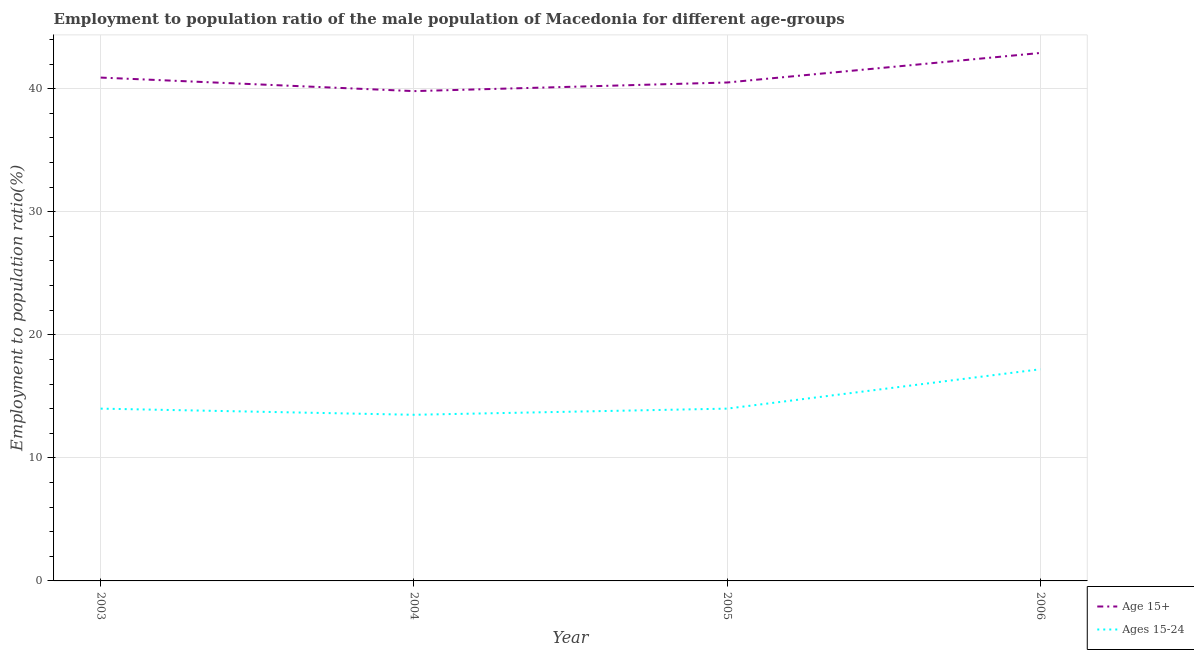What is the employment to population ratio(age 15+) in 2005?
Your response must be concise. 40.5. Across all years, what is the maximum employment to population ratio(age 15-24)?
Provide a short and direct response. 17.2. In which year was the employment to population ratio(age 15-24) minimum?
Provide a short and direct response. 2004. What is the total employment to population ratio(age 15-24) in the graph?
Give a very brief answer. 58.7. What is the difference between the employment to population ratio(age 15+) in 2003 and that in 2004?
Ensure brevity in your answer.  1.1. What is the difference between the employment to population ratio(age 15+) in 2004 and the employment to population ratio(age 15-24) in 2003?
Your answer should be compact. 25.8. What is the average employment to population ratio(age 15-24) per year?
Offer a very short reply. 14.68. In the year 2006, what is the difference between the employment to population ratio(age 15-24) and employment to population ratio(age 15+)?
Ensure brevity in your answer.  -25.7. In how many years, is the employment to population ratio(age 15+) greater than 24 %?
Offer a terse response. 4. What is the ratio of the employment to population ratio(age 15-24) in 2005 to that in 2006?
Offer a very short reply. 0.81. Is the employment to population ratio(age 15-24) in 2003 less than that in 2006?
Your answer should be compact. Yes. What is the difference between the highest and the lowest employment to population ratio(age 15-24)?
Provide a short and direct response. 3.7. In how many years, is the employment to population ratio(age 15-24) greater than the average employment to population ratio(age 15-24) taken over all years?
Your answer should be compact. 1. Does the employment to population ratio(age 15-24) monotonically increase over the years?
Offer a very short reply. No. How many lines are there?
Provide a short and direct response. 2. How many years are there in the graph?
Keep it short and to the point. 4. Does the graph contain grids?
Provide a short and direct response. Yes. How many legend labels are there?
Give a very brief answer. 2. How are the legend labels stacked?
Give a very brief answer. Vertical. What is the title of the graph?
Keep it short and to the point. Employment to population ratio of the male population of Macedonia for different age-groups. What is the Employment to population ratio(%) in Age 15+ in 2003?
Give a very brief answer. 40.9. What is the Employment to population ratio(%) of Ages 15-24 in 2003?
Your response must be concise. 14. What is the Employment to population ratio(%) of Age 15+ in 2004?
Provide a short and direct response. 39.8. What is the Employment to population ratio(%) in Ages 15-24 in 2004?
Provide a succinct answer. 13.5. What is the Employment to population ratio(%) in Age 15+ in 2005?
Offer a very short reply. 40.5. What is the Employment to population ratio(%) in Ages 15-24 in 2005?
Offer a terse response. 14. What is the Employment to population ratio(%) in Age 15+ in 2006?
Offer a very short reply. 42.9. What is the Employment to population ratio(%) of Ages 15-24 in 2006?
Keep it short and to the point. 17.2. Across all years, what is the maximum Employment to population ratio(%) in Age 15+?
Keep it short and to the point. 42.9. Across all years, what is the maximum Employment to population ratio(%) of Ages 15-24?
Your answer should be compact. 17.2. Across all years, what is the minimum Employment to population ratio(%) of Age 15+?
Make the answer very short. 39.8. Across all years, what is the minimum Employment to population ratio(%) of Ages 15-24?
Your response must be concise. 13.5. What is the total Employment to population ratio(%) of Age 15+ in the graph?
Your answer should be very brief. 164.1. What is the total Employment to population ratio(%) of Ages 15-24 in the graph?
Offer a very short reply. 58.7. What is the difference between the Employment to population ratio(%) in Age 15+ in 2003 and that in 2004?
Give a very brief answer. 1.1. What is the difference between the Employment to population ratio(%) in Age 15+ in 2003 and that in 2005?
Give a very brief answer. 0.4. What is the difference between the Employment to population ratio(%) of Ages 15-24 in 2003 and that in 2006?
Ensure brevity in your answer.  -3.2. What is the difference between the Employment to population ratio(%) in Ages 15-24 in 2004 and that in 2006?
Offer a very short reply. -3.7. What is the difference between the Employment to population ratio(%) in Ages 15-24 in 2005 and that in 2006?
Provide a succinct answer. -3.2. What is the difference between the Employment to population ratio(%) of Age 15+ in 2003 and the Employment to population ratio(%) of Ages 15-24 in 2004?
Your response must be concise. 27.4. What is the difference between the Employment to population ratio(%) of Age 15+ in 2003 and the Employment to population ratio(%) of Ages 15-24 in 2005?
Make the answer very short. 26.9. What is the difference between the Employment to population ratio(%) in Age 15+ in 2003 and the Employment to population ratio(%) in Ages 15-24 in 2006?
Your response must be concise. 23.7. What is the difference between the Employment to population ratio(%) in Age 15+ in 2004 and the Employment to population ratio(%) in Ages 15-24 in 2005?
Your answer should be very brief. 25.8. What is the difference between the Employment to population ratio(%) in Age 15+ in 2004 and the Employment to population ratio(%) in Ages 15-24 in 2006?
Your answer should be very brief. 22.6. What is the difference between the Employment to population ratio(%) of Age 15+ in 2005 and the Employment to population ratio(%) of Ages 15-24 in 2006?
Make the answer very short. 23.3. What is the average Employment to population ratio(%) of Age 15+ per year?
Offer a terse response. 41.02. What is the average Employment to population ratio(%) in Ages 15-24 per year?
Keep it short and to the point. 14.68. In the year 2003, what is the difference between the Employment to population ratio(%) in Age 15+ and Employment to population ratio(%) in Ages 15-24?
Provide a succinct answer. 26.9. In the year 2004, what is the difference between the Employment to population ratio(%) of Age 15+ and Employment to population ratio(%) of Ages 15-24?
Your response must be concise. 26.3. In the year 2006, what is the difference between the Employment to population ratio(%) in Age 15+ and Employment to population ratio(%) in Ages 15-24?
Give a very brief answer. 25.7. What is the ratio of the Employment to population ratio(%) in Age 15+ in 2003 to that in 2004?
Keep it short and to the point. 1.03. What is the ratio of the Employment to population ratio(%) in Ages 15-24 in 2003 to that in 2004?
Make the answer very short. 1.04. What is the ratio of the Employment to population ratio(%) of Age 15+ in 2003 to that in 2005?
Your answer should be very brief. 1.01. What is the ratio of the Employment to population ratio(%) of Ages 15-24 in 2003 to that in 2005?
Offer a very short reply. 1. What is the ratio of the Employment to population ratio(%) of Age 15+ in 2003 to that in 2006?
Offer a terse response. 0.95. What is the ratio of the Employment to population ratio(%) of Ages 15-24 in 2003 to that in 2006?
Provide a succinct answer. 0.81. What is the ratio of the Employment to population ratio(%) of Age 15+ in 2004 to that in 2005?
Offer a very short reply. 0.98. What is the ratio of the Employment to population ratio(%) in Age 15+ in 2004 to that in 2006?
Your answer should be very brief. 0.93. What is the ratio of the Employment to population ratio(%) in Ages 15-24 in 2004 to that in 2006?
Offer a terse response. 0.78. What is the ratio of the Employment to population ratio(%) of Age 15+ in 2005 to that in 2006?
Provide a short and direct response. 0.94. What is the ratio of the Employment to population ratio(%) in Ages 15-24 in 2005 to that in 2006?
Keep it short and to the point. 0.81. What is the difference between the highest and the second highest Employment to population ratio(%) of Age 15+?
Your response must be concise. 2. What is the difference between the highest and the second highest Employment to population ratio(%) of Ages 15-24?
Offer a very short reply. 3.2. What is the difference between the highest and the lowest Employment to population ratio(%) of Ages 15-24?
Ensure brevity in your answer.  3.7. 